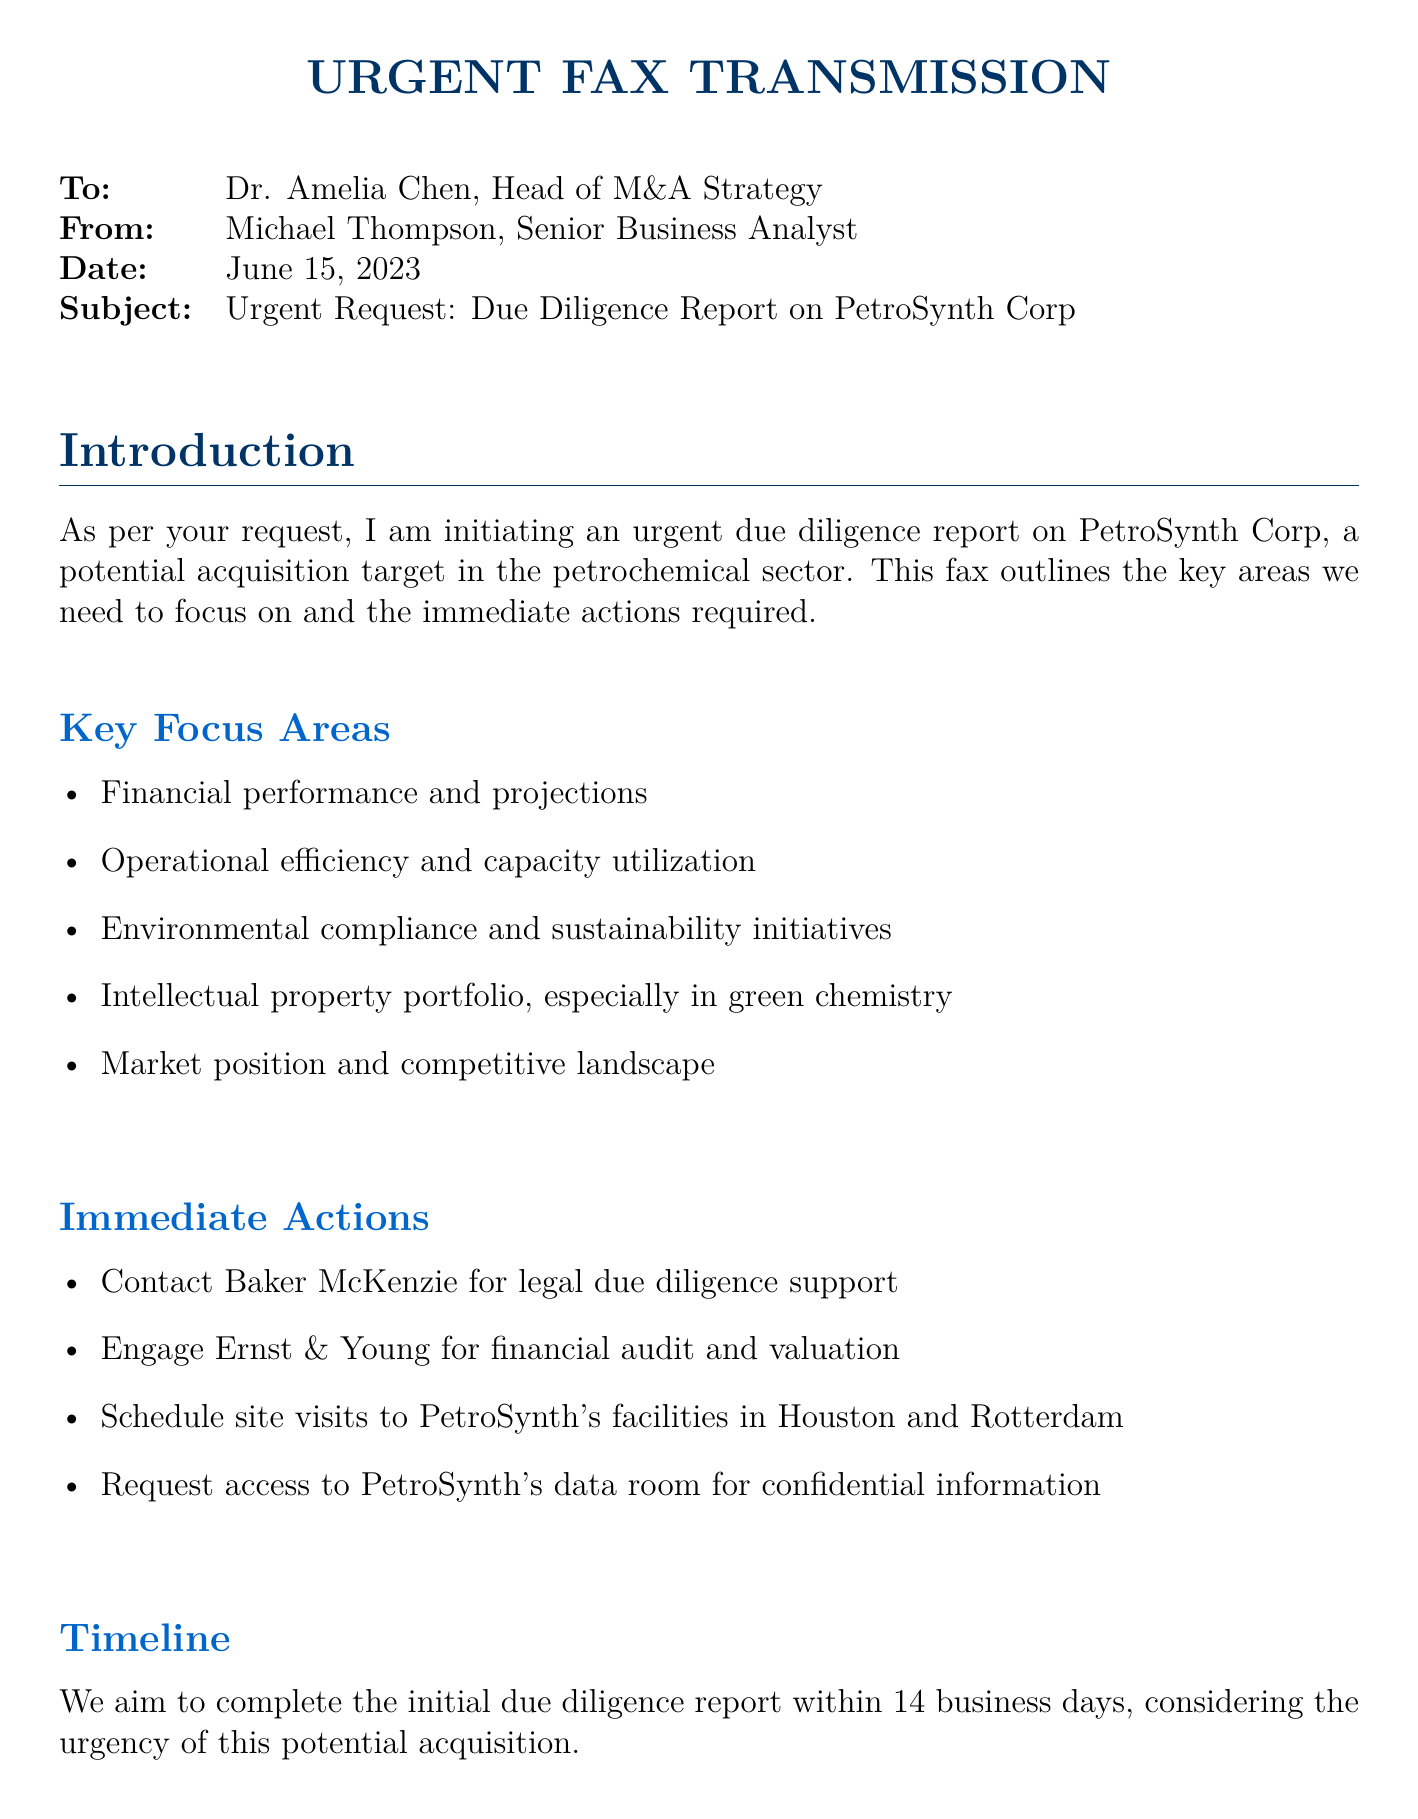What is the name of the potential acquisition target? The document states that the potential acquisition target is PetroSynth Corp.
Answer: PetroSynth Corp Who is the recipient of the fax? The document clearly states that the fax is addressed to Dr. Amelia Chen, Head of M&A Strategy.
Answer: Dr. Amelia Chen What is the submission date of the fax? The fax date is explicitly mentioned as June 15, 2023.
Answer: June 15, 2023 How many business days are allocated for the due diligence report? The document mentions an aim to complete the report within 14 business days.
Answer: 14 business days Which law firm is contacted for legal due diligence? The document specifies contacting Baker McKenzie for legal due diligence support.
Answer: Baker McKenzie What is one focus area mentioned in the due diligence report? The document lists multiple key focus areas, one of which is financial performance and projections.
Answer: Financial performance and projections What type of firm is Ernst & Young? The document indicates engaging Ernst & Young for a specific purpose, identifying them as a financial audit and valuation firm.
Answer: Financial audit and valuation Name one potential synergy identified in the document. Among the potential synergies identified is the integration with existing ethylene production capabilities.
Answer: Integration with existing ethylene production capabilities 